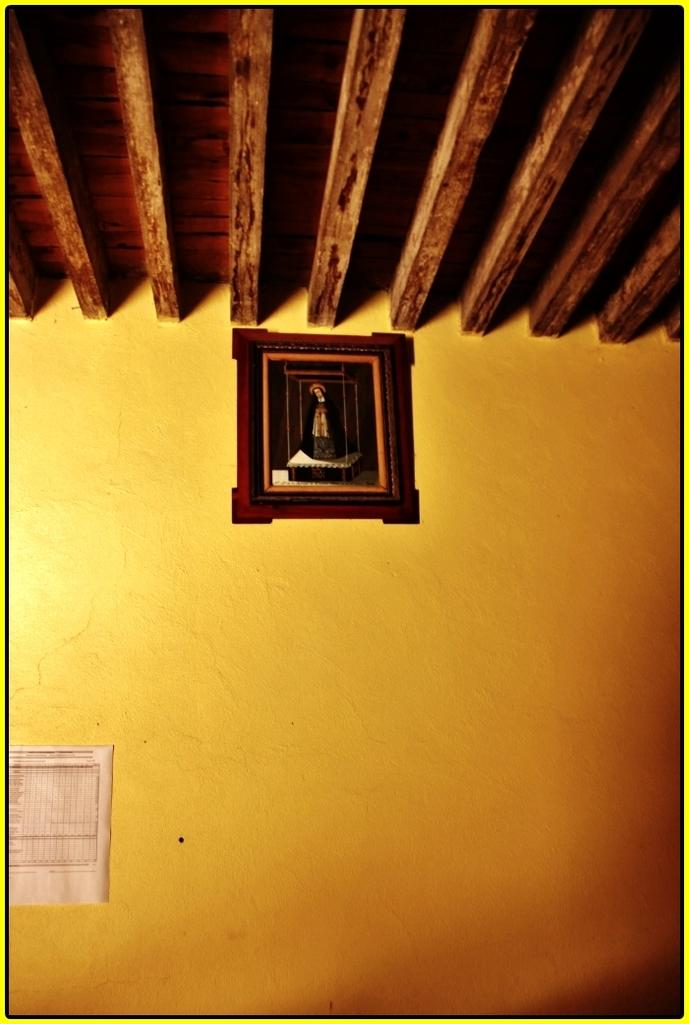What is hanging on the wall in the image? There is a photo frame and a paper on a wall in the image. What type of material is the roof made of in the image? The roof visible in the image is made of wood. How many boys are holding a thread in the image? There are no boys or thread present in the image. 